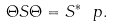<formula> <loc_0><loc_0><loc_500><loc_500>\Theta S \Theta = S ^ { * } \ p .</formula> 